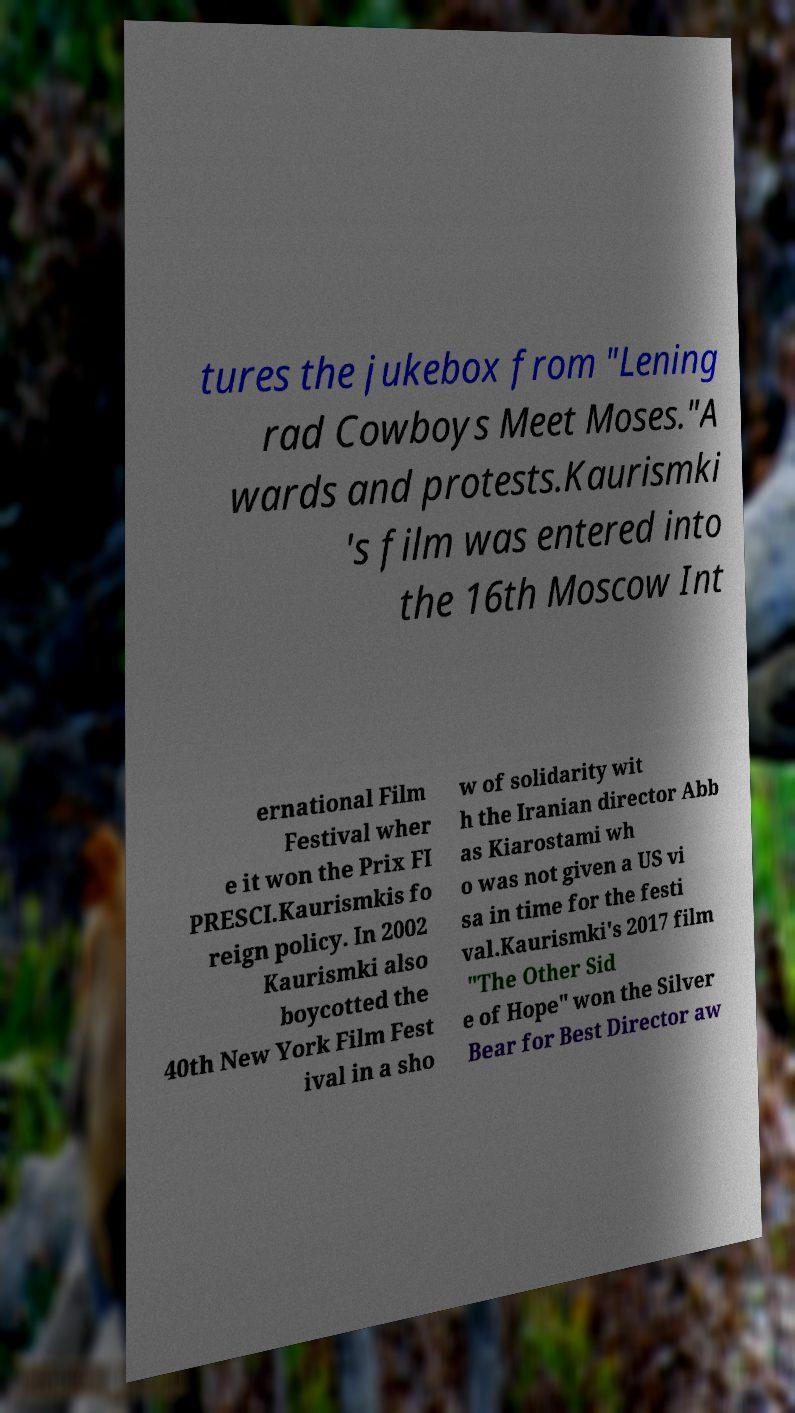I need the written content from this picture converted into text. Can you do that? tures the jukebox from "Lening rad Cowboys Meet Moses."A wards and protests.Kaurismki 's film was entered into the 16th Moscow Int ernational Film Festival wher e it won the Prix FI PRESCI.Kaurismkis fo reign policy. In 2002 Kaurismki also boycotted the 40th New York Film Fest ival in a sho w of solidarity wit h the Iranian director Abb as Kiarostami wh o was not given a US vi sa in time for the festi val.Kaurismki's 2017 film "The Other Sid e of Hope" won the Silver Bear for Best Director aw 